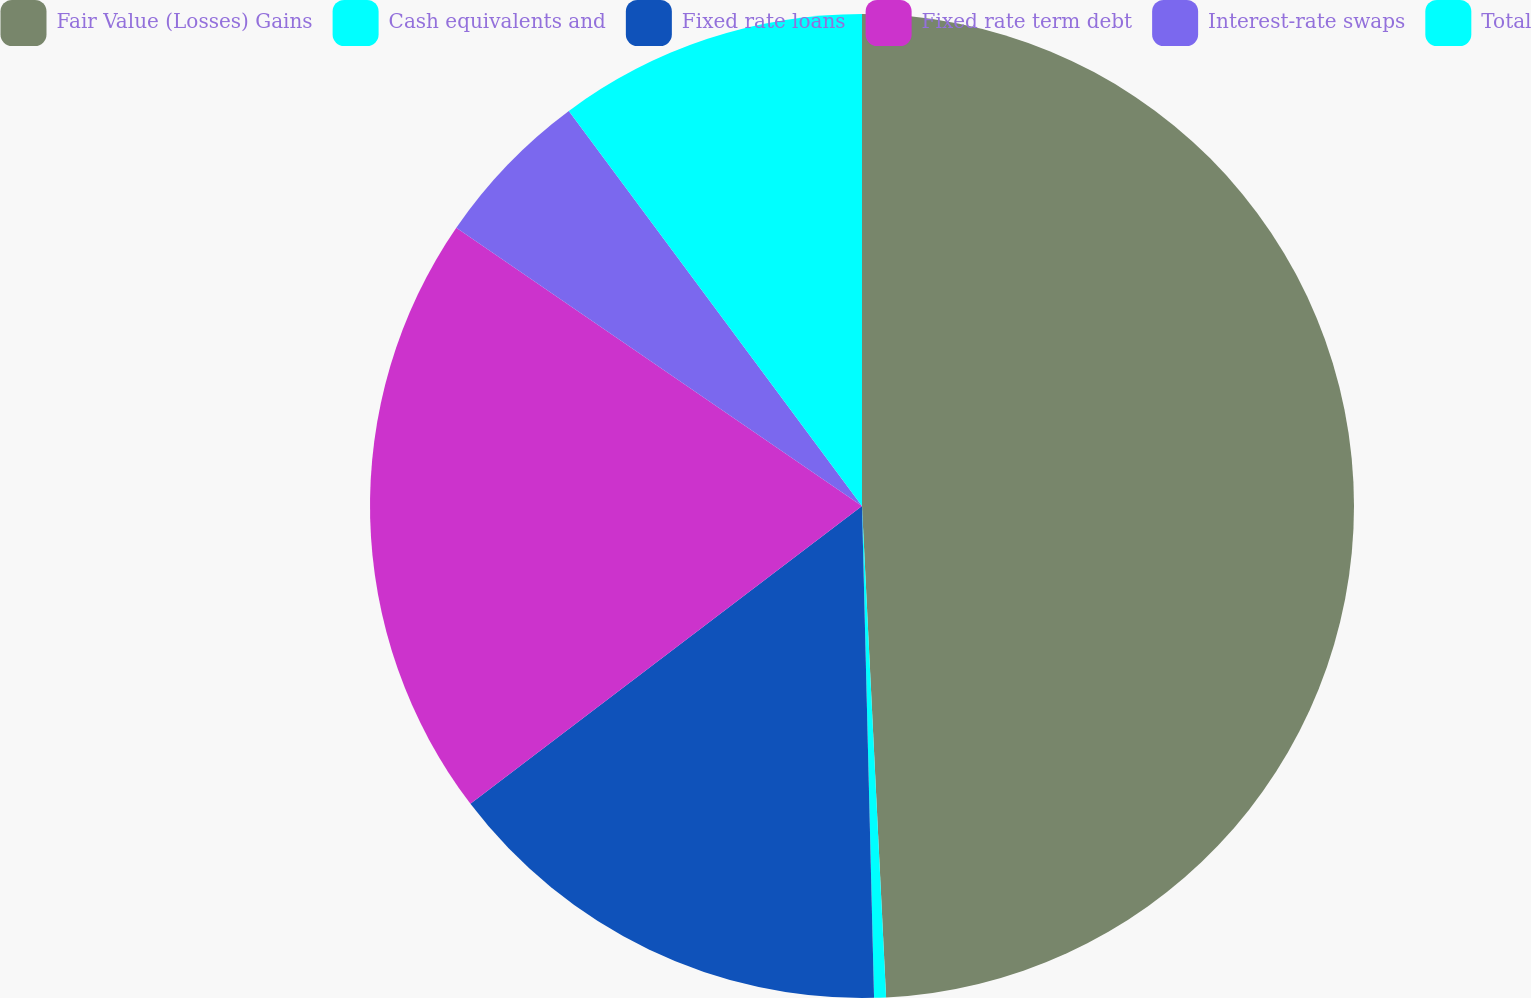Convert chart to OTSL. <chart><loc_0><loc_0><loc_500><loc_500><pie_chart><fcel>Fair Value (Losses) Gains<fcel>Cash equivalents and<fcel>Fixed rate loans<fcel>Fixed rate term debt<fcel>Interest-rate swaps<fcel>Total<nl><fcel>49.22%<fcel>0.39%<fcel>15.04%<fcel>19.92%<fcel>5.27%<fcel>10.16%<nl></chart> 